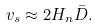Convert formula to latex. <formula><loc_0><loc_0><loc_500><loc_500>v _ { s } \approx 2 H _ { n } \bar { D } .</formula> 